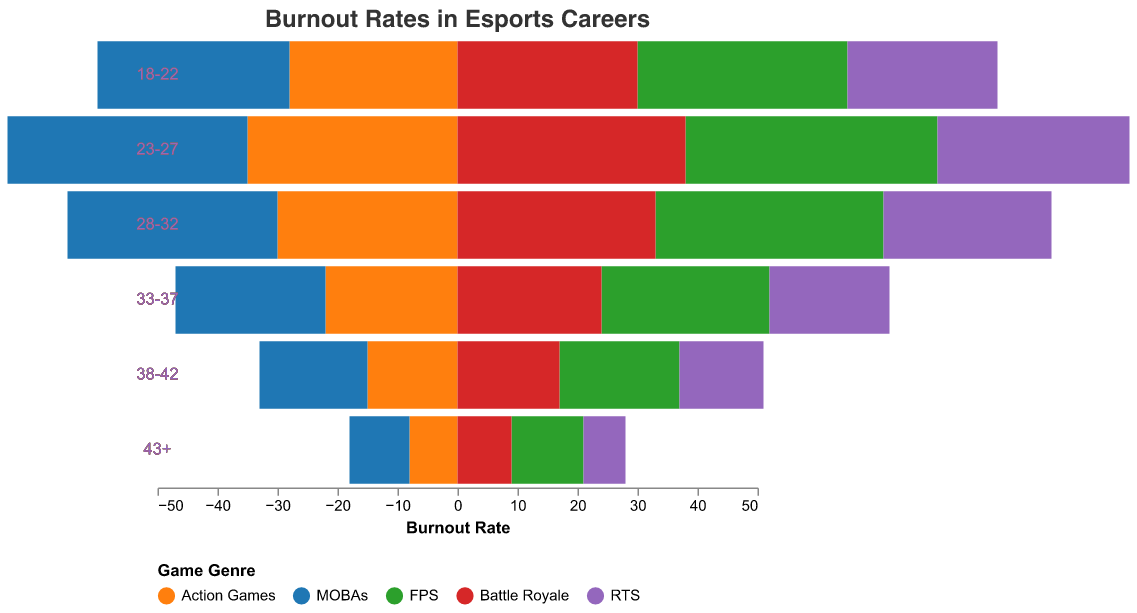What is the burnout rate for FPS players aged 23-27? To find the burnout rate for FPS players aged 23-27, locate the "23-27" age range and then look at the value in the "FPS" column.
Answer: 42 What game genre has the highest burnout rate for the 18-22 age range? To determine the game genre with the highest burnout rate for the 18-22 age range, compare the values for each genre within this age range. The values are 28 (Action Games), 32 (MOBAs), 35 (FPS), 30 (Battle Royale), and 25 (RTS).
Answer: FPS Which age range shows a consistent drop in burnout rates across all game genres compared to the previous age range? Observe the changes in burnout rates from one age range to the next for all game genres. Notably, from 23-27 to 28-32, all genres show a drop in burnout rates.
Answer: 28-32 How do burnout rates for RTS games compare between the youngest (18-22) and oldest (43+) age ranges? Compare the burnout rate value for RTS games in the 18-22 age range (25) and the 43+ age range (7). The decrease shows that the burnout rate is higher in the younger age range.
Answer: Higher in 18-22 What is the average burnout rate for MOBAs across all age ranges? To calculate the average burnout rate for MOBAs, sum the burnout rates across all age ranges (32, 40, 35, 25, 18, 10) and divide by the number of age ranges (6). The sum is 160, so the average is 160/6.
Answer: 26.67 Which game genre has the steepest decline in burnout rate from the 23-27 to the 33-37 age range? Calculate the decline in burnout rates from the 23-27 to the 33-37 age range for each genre: Action Games (35 - 22 = 13), MOBAs (40 - 25 = 15), FPS (42 - 28 = 14), Battle Royale (38 - 24 = 14), RTS (32 - 20 = 12). The steepest decline is for MOBAs.
Answer: MOBAs What is the difference in burnout rates for the 33-37 age range between Action Games and Battle Royale? Subtract the burnout rate for Battle Royale (24) from the burnout rate for Action Games (22) in the 33-37 age range. The result is 22 - 24.
Answer: -2 How many age ranges have burnout rates above 30 for FPS players? Count the number of age ranges where the burnout rate for FPS players is greater than 30. These age ranges are "18-22", "23-27", and "28-32".
Answer: 3 In which age range do Battle Royale and MOBAs have an equal burnout rate? Compare the burnout rates of Battle Royale and MOBAs in each age range. They are both 35 in the "28-32" age range.
Answer: 28-32 